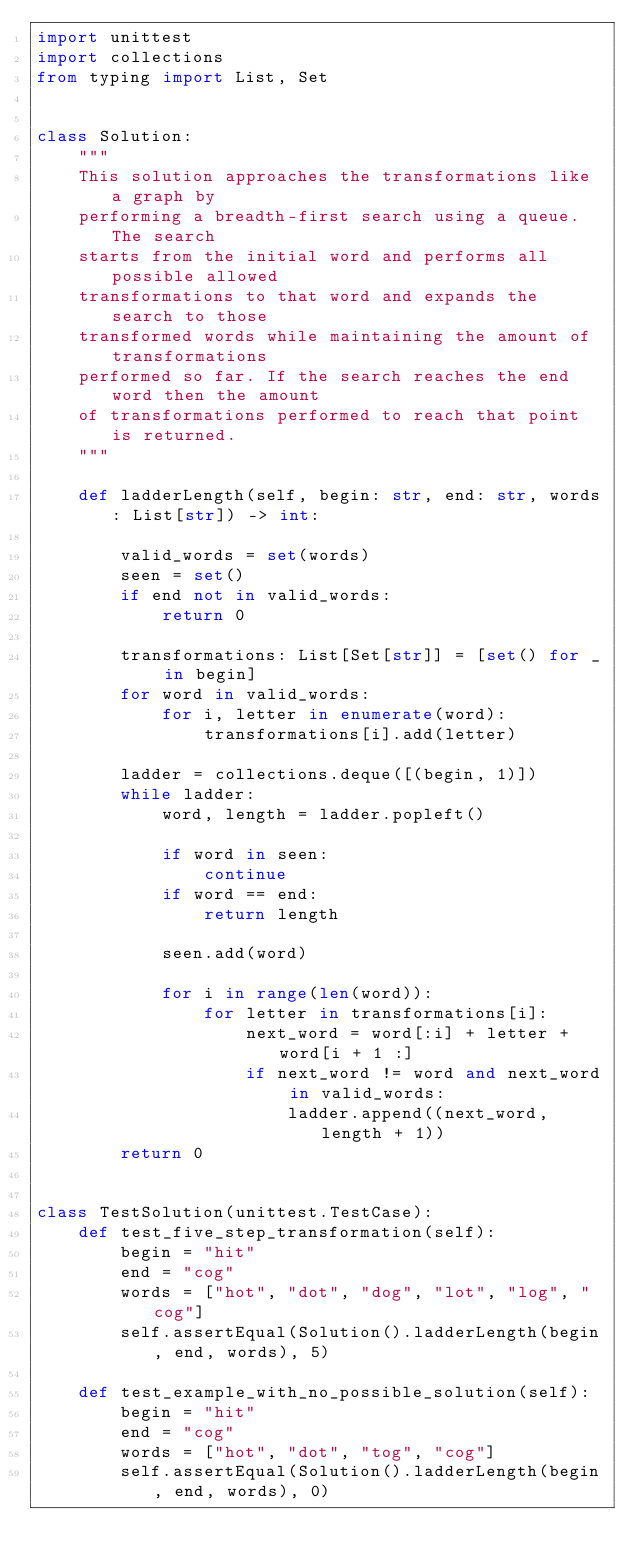Convert code to text. <code><loc_0><loc_0><loc_500><loc_500><_Python_>import unittest
import collections
from typing import List, Set


class Solution:
    """
    This solution approaches the transformations like a graph by
    performing a breadth-first search using a queue. The search
    starts from the initial word and performs all possible allowed
    transformations to that word and expands the search to those
    transformed words while maintaining the amount of transformations
    performed so far. If the search reaches the end word then the amount
    of transformations performed to reach that point is returned.
    """

    def ladderLength(self, begin: str, end: str, words: List[str]) -> int:

        valid_words = set(words)
        seen = set()
        if end not in valid_words:
            return 0

        transformations: List[Set[str]] = [set() for _ in begin]
        for word in valid_words:
            for i, letter in enumerate(word):
                transformations[i].add(letter)

        ladder = collections.deque([(begin, 1)])
        while ladder:
            word, length = ladder.popleft()

            if word in seen:
                continue
            if word == end:
                return length

            seen.add(word)

            for i in range(len(word)):
                for letter in transformations[i]:
                    next_word = word[:i] + letter + word[i + 1 :]
                    if next_word != word and next_word in valid_words:
                        ladder.append((next_word, length + 1))
        return 0


class TestSolution(unittest.TestCase):
    def test_five_step_transformation(self):
        begin = "hit"
        end = "cog"
        words = ["hot", "dot", "dog", "lot", "log", "cog"]
        self.assertEqual(Solution().ladderLength(begin, end, words), 5)

    def test_example_with_no_possible_solution(self):
        begin = "hit"
        end = "cog"
        words = ["hot", "dot", "tog", "cog"]
        self.assertEqual(Solution().ladderLength(begin, end, words), 0)

</code> 